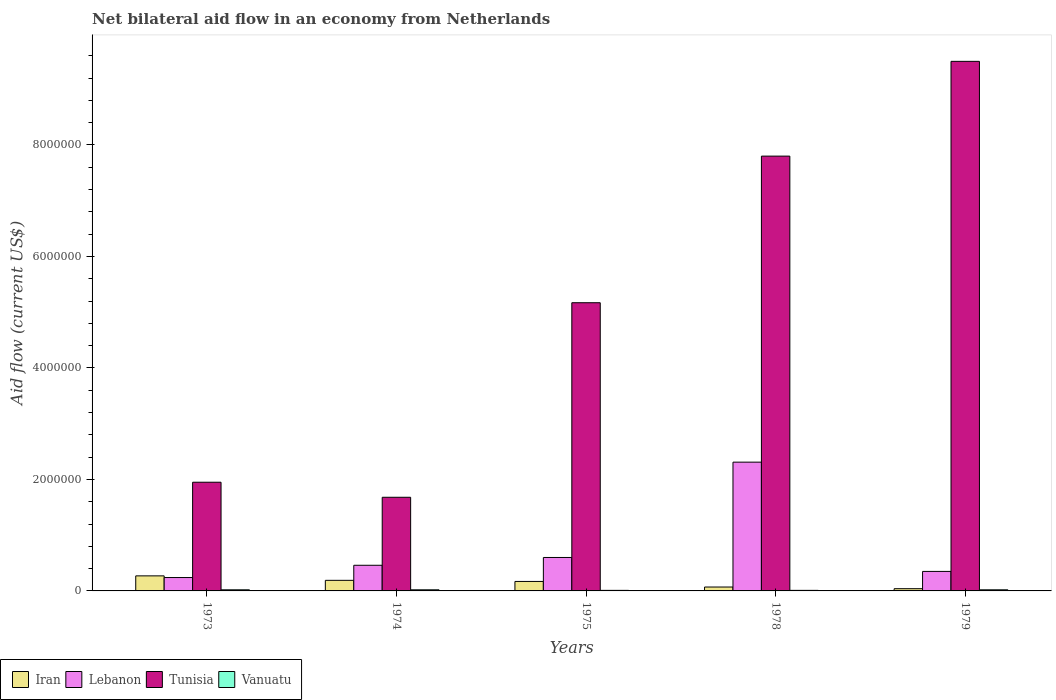How many different coloured bars are there?
Your response must be concise. 4. How many bars are there on the 3rd tick from the left?
Offer a very short reply. 4. What is the label of the 2nd group of bars from the left?
Your answer should be compact. 1974. In how many cases, is the number of bars for a given year not equal to the number of legend labels?
Provide a succinct answer. 0. What is the net bilateral aid flow in Iran in 1975?
Keep it short and to the point. 1.70e+05. Across all years, what is the maximum net bilateral aid flow in Iran?
Keep it short and to the point. 2.70e+05. Across all years, what is the minimum net bilateral aid flow in Tunisia?
Keep it short and to the point. 1.68e+06. In which year was the net bilateral aid flow in Vanuatu maximum?
Provide a short and direct response. 1973. In which year was the net bilateral aid flow in Tunisia minimum?
Keep it short and to the point. 1974. What is the total net bilateral aid flow in Vanuatu in the graph?
Provide a succinct answer. 8.00e+04. What is the difference between the net bilateral aid flow in Iran in 1975 and that in 1978?
Keep it short and to the point. 1.00e+05. What is the average net bilateral aid flow in Vanuatu per year?
Provide a short and direct response. 1.60e+04. In the year 1974, what is the difference between the net bilateral aid flow in Lebanon and net bilateral aid flow in Vanuatu?
Your answer should be very brief. 4.40e+05. What is the difference between the highest and the second highest net bilateral aid flow in Lebanon?
Offer a very short reply. 1.71e+06. What is the difference between the highest and the lowest net bilateral aid flow in Lebanon?
Give a very brief answer. 2.07e+06. In how many years, is the net bilateral aid flow in Lebanon greater than the average net bilateral aid flow in Lebanon taken over all years?
Ensure brevity in your answer.  1. Is the sum of the net bilateral aid flow in Iran in 1978 and 1979 greater than the maximum net bilateral aid flow in Vanuatu across all years?
Ensure brevity in your answer.  Yes. Is it the case that in every year, the sum of the net bilateral aid flow in Vanuatu and net bilateral aid flow in Iran is greater than the sum of net bilateral aid flow in Tunisia and net bilateral aid flow in Lebanon?
Offer a very short reply. Yes. What does the 1st bar from the left in 1978 represents?
Keep it short and to the point. Iran. What does the 4th bar from the right in 1978 represents?
Keep it short and to the point. Iran. Are all the bars in the graph horizontal?
Provide a short and direct response. No. Are the values on the major ticks of Y-axis written in scientific E-notation?
Make the answer very short. No. Where does the legend appear in the graph?
Your answer should be compact. Bottom left. How are the legend labels stacked?
Give a very brief answer. Horizontal. What is the title of the graph?
Make the answer very short. Net bilateral aid flow in an economy from Netherlands. What is the label or title of the X-axis?
Keep it short and to the point. Years. What is the label or title of the Y-axis?
Keep it short and to the point. Aid flow (current US$). What is the Aid flow (current US$) in Iran in 1973?
Make the answer very short. 2.70e+05. What is the Aid flow (current US$) in Tunisia in 1973?
Provide a short and direct response. 1.95e+06. What is the Aid flow (current US$) of Vanuatu in 1973?
Provide a short and direct response. 2.00e+04. What is the Aid flow (current US$) of Tunisia in 1974?
Your answer should be compact. 1.68e+06. What is the Aid flow (current US$) of Vanuatu in 1974?
Ensure brevity in your answer.  2.00e+04. What is the Aid flow (current US$) in Lebanon in 1975?
Give a very brief answer. 6.00e+05. What is the Aid flow (current US$) of Tunisia in 1975?
Your response must be concise. 5.17e+06. What is the Aid flow (current US$) of Lebanon in 1978?
Your answer should be compact. 2.31e+06. What is the Aid flow (current US$) in Tunisia in 1978?
Offer a very short reply. 7.80e+06. What is the Aid flow (current US$) of Iran in 1979?
Provide a succinct answer. 4.00e+04. What is the Aid flow (current US$) in Lebanon in 1979?
Keep it short and to the point. 3.50e+05. What is the Aid flow (current US$) of Tunisia in 1979?
Make the answer very short. 9.50e+06. What is the Aid flow (current US$) in Vanuatu in 1979?
Keep it short and to the point. 2.00e+04. Across all years, what is the maximum Aid flow (current US$) of Lebanon?
Keep it short and to the point. 2.31e+06. Across all years, what is the maximum Aid flow (current US$) of Tunisia?
Offer a very short reply. 9.50e+06. Across all years, what is the maximum Aid flow (current US$) of Vanuatu?
Provide a short and direct response. 2.00e+04. Across all years, what is the minimum Aid flow (current US$) in Iran?
Ensure brevity in your answer.  4.00e+04. Across all years, what is the minimum Aid flow (current US$) of Lebanon?
Offer a terse response. 2.40e+05. Across all years, what is the minimum Aid flow (current US$) of Tunisia?
Your answer should be compact. 1.68e+06. What is the total Aid flow (current US$) of Iran in the graph?
Your answer should be compact. 7.40e+05. What is the total Aid flow (current US$) of Lebanon in the graph?
Your response must be concise. 3.96e+06. What is the total Aid flow (current US$) of Tunisia in the graph?
Provide a short and direct response. 2.61e+07. What is the total Aid flow (current US$) in Vanuatu in the graph?
Give a very brief answer. 8.00e+04. What is the difference between the Aid flow (current US$) of Tunisia in 1973 and that in 1974?
Offer a terse response. 2.70e+05. What is the difference between the Aid flow (current US$) of Iran in 1973 and that in 1975?
Offer a terse response. 1.00e+05. What is the difference between the Aid flow (current US$) in Lebanon in 1973 and that in 1975?
Provide a succinct answer. -3.60e+05. What is the difference between the Aid flow (current US$) in Tunisia in 1973 and that in 1975?
Keep it short and to the point. -3.22e+06. What is the difference between the Aid flow (current US$) in Iran in 1973 and that in 1978?
Your answer should be very brief. 2.00e+05. What is the difference between the Aid flow (current US$) in Lebanon in 1973 and that in 1978?
Offer a terse response. -2.07e+06. What is the difference between the Aid flow (current US$) in Tunisia in 1973 and that in 1978?
Provide a short and direct response. -5.85e+06. What is the difference between the Aid flow (current US$) of Vanuatu in 1973 and that in 1978?
Your answer should be compact. 10000. What is the difference between the Aid flow (current US$) of Lebanon in 1973 and that in 1979?
Give a very brief answer. -1.10e+05. What is the difference between the Aid flow (current US$) in Tunisia in 1973 and that in 1979?
Keep it short and to the point. -7.55e+06. What is the difference between the Aid flow (current US$) in Vanuatu in 1973 and that in 1979?
Give a very brief answer. 0. What is the difference between the Aid flow (current US$) in Iran in 1974 and that in 1975?
Make the answer very short. 2.00e+04. What is the difference between the Aid flow (current US$) of Tunisia in 1974 and that in 1975?
Offer a terse response. -3.49e+06. What is the difference between the Aid flow (current US$) of Vanuatu in 1974 and that in 1975?
Your answer should be compact. 10000. What is the difference between the Aid flow (current US$) of Iran in 1974 and that in 1978?
Your answer should be very brief. 1.20e+05. What is the difference between the Aid flow (current US$) of Lebanon in 1974 and that in 1978?
Offer a very short reply. -1.85e+06. What is the difference between the Aid flow (current US$) in Tunisia in 1974 and that in 1978?
Keep it short and to the point. -6.12e+06. What is the difference between the Aid flow (current US$) in Tunisia in 1974 and that in 1979?
Ensure brevity in your answer.  -7.82e+06. What is the difference between the Aid flow (current US$) of Vanuatu in 1974 and that in 1979?
Make the answer very short. 0. What is the difference between the Aid flow (current US$) in Lebanon in 1975 and that in 1978?
Provide a short and direct response. -1.71e+06. What is the difference between the Aid flow (current US$) in Tunisia in 1975 and that in 1978?
Offer a very short reply. -2.63e+06. What is the difference between the Aid flow (current US$) of Vanuatu in 1975 and that in 1978?
Provide a short and direct response. 0. What is the difference between the Aid flow (current US$) in Tunisia in 1975 and that in 1979?
Ensure brevity in your answer.  -4.33e+06. What is the difference between the Aid flow (current US$) of Vanuatu in 1975 and that in 1979?
Provide a short and direct response. -10000. What is the difference between the Aid flow (current US$) in Iran in 1978 and that in 1979?
Your response must be concise. 3.00e+04. What is the difference between the Aid flow (current US$) in Lebanon in 1978 and that in 1979?
Keep it short and to the point. 1.96e+06. What is the difference between the Aid flow (current US$) of Tunisia in 1978 and that in 1979?
Your response must be concise. -1.70e+06. What is the difference between the Aid flow (current US$) in Iran in 1973 and the Aid flow (current US$) in Lebanon in 1974?
Your answer should be compact. -1.90e+05. What is the difference between the Aid flow (current US$) of Iran in 1973 and the Aid flow (current US$) of Tunisia in 1974?
Your answer should be compact. -1.41e+06. What is the difference between the Aid flow (current US$) of Lebanon in 1973 and the Aid flow (current US$) of Tunisia in 1974?
Offer a terse response. -1.44e+06. What is the difference between the Aid flow (current US$) of Lebanon in 1973 and the Aid flow (current US$) of Vanuatu in 1974?
Make the answer very short. 2.20e+05. What is the difference between the Aid flow (current US$) in Tunisia in 1973 and the Aid flow (current US$) in Vanuatu in 1974?
Your response must be concise. 1.93e+06. What is the difference between the Aid flow (current US$) in Iran in 1973 and the Aid flow (current US$) in Lebanon in 1975?
Provide a short and direct response. -3.30e+05. What is the difference between the Aid flow (current US$) in Iran in 1973 and the Aid flow (current US$) in Tunisia in 1975?
Your response must be concise. -4.90e+06. What is the difference between the Aid flow (current US$) in Iran in 1973 and the Aid flow (current US$) in Vanuatu in 1975?
Give a very brief answer. 2.60e+05. What is the difference between the Aid flow (current US$) in Lebanon in 1973 and the Aid flow (current US$) in Tunisia in 1975?
Offer a terse response. -4.93e+06. What is the difference between the Aid flow (current US$) in Tunisia in 1973 and the Aid flow (current US$) in Vanuatu in 1975?
Provide a short and direct response. 1.94e+06. What is the difference between the Aid flow (current US$) in Iran in 1973 and the Aid flow (current US$) in Lebanon in 1978?
Keep it short and to the point. -2.04e+06. What is the difference between the Aid flow (current US$) of Iran in 1973 and the Aid flow (current US$) of Tunisia in 1978?
Make the answer very short. -7.53e+06. What is the difference between the Aid flow (current US$) of Iran in 1973 and the Aid flow (current US$) of Vanuatu in 1978?
Your answer should be compact. 2.60e+05. What is the difference between the Aid flow (current US$) of Lebanon in 1973 and the Aid flow (current US$) of Tunisia in 1978?
Provide a short and direct response. -7.56e+06. What is the difference between the Aid flow (current US$) of Lebanon in 1973 and the Aid flow (current US$) of Vanuatu in 1978?
Give a very brief answer. 2.30e+05. What is the difference between the Aid flow (current US$) in Tunisia in 1973 and the Aid flow (current US$) in Vanuatu in 1978?
Ensure brevity in your answer.  1.94e+06. What is the difference between the Aid flow (current US$) in Iran in 1973 and the Aid flow (current US$) in Tunisia in 1979?
Give a very brief answer. -9.23e+06. What is the difference between the Aid flow (current US$) in Iran in 1973 and the Aid flow (current US$) in Vanuatu in 1979?
Give a very brief answer. 2.50e+05. What is the difference between the Aid flow (current US$) of Lebanon in 1973 and the Aid flow (current US$) of Tunisia in 1979?
Your answer should be compact. -9.26e+06. What is the difference between the Aid flow (current US$) of Tunisia in 1973 and the Aid flow (current US$) of Vanuatu in 1979?
Provide a short and direct response. 1.93e+06. What is the difference between the Aid flow (current US$) of Iran in 1974 and the Aid flow (current US$) of Lebanon in 1975?
Your answer should be very brief. -4.10e+05. What is the difference between the Aid flow (current US$) in Iran in 1974 and the Aid flow (current US$) in Tunisia in 1975?
Offer a terse response. -4.98e+06. What is the difference between the Aid flow (current US$) of Iran in 1974 and the Aid flow (current US$) of Vanuatu in 1975?
Your answer should be very brief. 1.80e+05. What is the difference between the Aid flow (current US$) of Lebanon in 1974 and the Aid flow (current US$) of Tunisia in 1975?
Keep it short and to the point. -4.71e+06. What is the difference between the Aid flow (current US$) of Lebanon in 1974 and the Aid flow (current US$) of Vanuatu in 1975?
Your answer should be compact. 4.50e+05. What is the difference between the Aid flow (current US$) of Tunisia in 1974 and the Aid flow (current US$) of Vanuatu in 1975?
Give a very brief answer. 1.67e+06. What is the difference between the Aid flow (current US$) in Iran in 1974 and the Aid flow (current US$) in Lebanon in 1978?
Your answer should be compact. -2.12e+06. What is the difference between the Aid flow (current US$) in Iran in 1974 and the Aid flow (current US$) in Tunisia in 1978?
Offer a terse response. -7.61e+06. What is the difference between the Aid flow (current US$) of Lebanon in 1974 and the Aid flow (current US$) of Tunisia in 1978?
Your answer should be compact. -7.34e+06. What is the difference between the Aid flow (current US$) of Lebanon in 1974 and the Aid flow (current US$) of Vanuatu in 1978?
Your response must be concise. 4.50e+05. What is the difference between the Aid flow (current US$) of Tunisia in 1974 and the Aid flow (current US$) of Vanuatu in 1978?
Offer a terse response. 1.67e+06. What is the difference between the Aid flow (current US$) in Iran in 1974 and the Aid flow (current US$) in Lebanon in 1979?
Your answer should be very brief. -1.60e+05. What is the difference between the Aid flow (current US$) of Iran in 1974 and the Aid flow (current US$) of Tunisia in 1979?
Offer a terse response. -9.31e+06. What is the difference between the Aid flow (current US$) of Iran in 1974 and the Aid flow (current US$) of Vanuatu in 1979?
Give a very brief answer. 1.70e+05. What is the difference between the Aid flow (current US$) in Lebanon in 1974 and the Aid flow (current US$) in Tunisia in 1979?
Offer a terse response. -9.04e+06. What is the difference between the Aid flow (current US$) of Lebanon in 1974 and the Aid flow (current US$) of Vanuatu in 1979?
Ensure brevity in your answer.  4.40e+05. What is the difference between the Aid flow (current US$) of Tunisia in 1974 and the Aid flow (current US$) of Vanuatu in 1979?
Keep it short and to the point. 1.66e+06. What is the difference between the Aid flow (current US$) in Iran in 1975 and the Aid flow (current US$) in Lebanon in 1978?
Your answer should be very brief. -2.14e+06. What is the difference between the Aid flow (current US$) in Iran in 1975 and the Aid flow (current US$) in Tunisia in 1978?
Give a very brief answer. -7.63e+06. What is the difference between the Aid flow (current US$) in Lebanon in 1975 and the Aid flow (current US$) in Tunisia in 1978?
Provide a short and direct response. -7.20e+06. What is the difference between the Aid flow (current US$) in Lebanon in 1975 and the Aid flow (current US$) in Vanuatu in 1978?
Offer a very short reply. 5.90e+05. What is the difference between the Aid flow (current US$) in Tunisia in 1975 and the Aid flow (current US$) in Vanuatu in 1978?
Give a very brief answer. 5.16e+06. What is the difference between the Aid flow (current US$) in Iran in 1975 and the Aid flow (current US$) in Tunisia in 1979?
Offer a very short reply. -9.33e+06. What is the difference between the Aid flow (current US$) in Lebanon in 1975 and the Aid flow (current US$) in Tunisia in 1979?
Make the answer very short. -8.90e+06. What is the difference between the Aid flow (current US$) in Lebanon in 1975 and the Aid flow (current US$) in Vanuatu in 1979?
Ensure brevity in your answer.  5.80e+05. What is the difference between the Aid flow (current US$) of Tunisia in 1975 and the Aid flow (current US$) of Vanuatu in 1979?
Make the answer very short. 5.15e+06. What is the difference between the Aid flow (current US$) in Iran in 1978 and the Aid flow (current US$) in Lebanon in 1979?
Provide a short and direct response. -2.80e+05. What is the difference between the Aid flow (current US$) in Iran in 1978 and the Aid flow (current US$) in Tunisia in 1979?
Provide a succinct answer. -9.43e+06. What is the difference between the Aid flow (current US$) in Iran in 1978 and the Aid flow (current US$) in Vanuatu in 1979?
Offer a terse response. 5.00e+04. What is the difference between the Aid flow (current US$) of Lebanon in 1978 and the Aid flow (current US$) of Tunisia in 1979?
Provide a short and direct response. -7.19e+06. What is the difference between the Aid flow (current US$) in Lebanon in 1978 and the Aid flow (current US$) in Vanuatu in 1979?
Your answer should be very brief. 2.29e+06. What is the difference between the Aid flow (current US$) of Tunisia in 1978 and the Aid flow (current US$) of Vanuatu in 1979?
Offer a terse response. 7.78e+06. What is the average Aid flow (current US$) of Iran per year?
Give a very brief answer. 1.48e+05. What is the average Aid flow (current US$) of Lebanon per year?
Keep it short and to the point. 7.92e+05. What is the average Aid flow (current US$) in Tunisia per year?
Ensure brevity in your answer.  5.22e+06. What is the average Aid flow (current US$) in Vanuatu per year?
Give a very brief answer. 1.60e+04. In the year 1973, what is the difference between the Aid flow (current US$) in Iran and Aid flow (current US$) in Tunisia?
Your answer should be very brief. -1.68e+06. In the year 1973, what is the difference between the Aid flow (current US$) in Lebanon and Aid flow (current US$) in Tunisia?
Your answer should be compact. -1.71e+06. In the year 1973, what is the difference between the Aid flow (current US$) in Lebanon and Aid flow (current US$) in Vanuatu?
Ensure brevity in your answer.  2.20e+05. In the year 1973, what is the difference between the Aid flow (current US$) of Tunisia and Aid flow (current US$) of Vanuatu?
Ensure brevity in your answer.  1.93e+06. In the year 1974, what is the difference between the Aid flow (current US$) in Iran and Aid flow (current US$) in Tunisia?
Provide a succinct answer. -1.49e+06. In the year 1974, what is the difference between the Aid flow (current US$) in Iran and Aid flow (current US$) in Vanuatu?
Give a very brief answer. 1.70e+05. In the year 1974, what is the difference between the Aid flow (current US$) in Lebanon and Aid flow (current US$) in Tunisia?
Give a very brief answer. -1.22e+06. In the year 1974, what is the difference between the Aid flow (current US$) of Tunisia and Aid flow (current US$) of Vanuatu?
Make the answer very short. 1.66e+06. In the year 1975, what is the difference between the Aid flow (current US$) of Iran and Aid flow (current US$) of Lebanon?
Give a very brief answer. -4.30e+05. In the year 1975, what is the difference between the Aid flow (current US$) of Iran and Aid flow (current US$) of Tunisia?
Your response must be concise. -5.00e+06. In the year 1975, what is the difference between the Aid flow (current US$) in Lebanon and Aid flow (current US$) in Tunisia?
Offer a very short reply. -4.57e+06. In the year 1975, what is the difference between the Aid flow (current US$) in Lebanon and Aid flow (current US$) in Vanuatu?
Make the answer very short. 5.90e+05. In the year 1975, what is the difference between the Aid flow (current US$) of Tunisia and Aid flow (current US$) of Vanuatu?
Give a very brief answer. 5.16e+06. In the year 1978, what is the difference between the Aid flow (current US$) of Iran and Aid flow (current US$) of Lebanon?
Your response must be concise. -2.24e+06. In the year 1978, what is the difference between the Aid flow (current US$) in Iran and Aid flow (current US$) in Tunisia?
Your answer should be very brief. -7.73e+06. In the year 1978, what is the difference between the Aid flow (current US$) in Lebanon and Aid flow (current US$) in Tunisia?
Your answer should be very brief. -5.49e+06. In the year 1978, what is the difference between the Aid flow (current US$) in Lebanon and Aid flow (current US$) in Vanuatu?
Offer a terse response. 2.30e+06. In the year 1978, what is the difference between the Aid flow (current US$) in Tunisia and Aid flow (current US$) in Vanuatu?
Make the answer very short. 7.79e+06. In the year 1979, what is the difference between the Aid flow (current US$) in Iran and Aid flow (current US$) in Lebanon?
Offer a very short reply. -3.10e+05. In the year 1979, what is the difference between the Aid flow (current US$) of Iran and Aid flow (current US$) of Tunisia?
Give a very brief answer. -9.46e+06. In the year 1979, what is the difference between the Aid flow (current US$) of Lebanon and Aid flow (current US$) of Tunisia?
Keep it short and to the point. -9.15e+06. In the year 1979, what is the difference between the Aid flow (current US$) in Lebanon and Aid flow (current US$) in Vanuatu?
Give a very brief answer. 3.30e+05. In the year 1979, what is the difference between the Aid flow (current US$) in Tunisia and Aid flow (current US$) in Vanuatu?
Offer a very short reply. 9.48e+06. What is the ratio of the Aid flow (current US$) of Iran in 1973 to that in 1974?
Your answer should be very brief. 1.42. What is the ratio of the Aid flow (current US$) in Lebanon in 1973 to that in 1974?
Keep it short and to the point. 0.52. What is the ratio of the Aid flow (current US$) of Tunisia in 1973 to that in 1974?
Provide a succinct answer. 1.16. What is the ratio of the Aid flow (current US$) in Vanuatu in 1973 to that in 1974?
Ensure brevity in your answer.  1. What is the ratio of the Aid flow (current US$) of Iran in 1973 to that in 1975?
Keep it short and to the point. 1.59. What is the ratio of the Aid flow (current US$) of Lebanon in 1973 to that in 1975?
Offer a terse response. 0.4. What is the ratio of the Aid flow (current US$) in Tunisia in 1973 to that in 1975?
Ensure brevity in your answer.  0.38. What is the ratio of the Aid flow (current US$) of Vanuatu in 1973 to that in 1975?
Ensure brevity in your answer.  2. What is the ratio of the Aid flow (current US$) in Iran in 1973 to that in 1978?
Make the answer very short. 3.86. What is the ratio of the Aid flow (current US$) in Lebanon in 1973 to that in 1978?
Keep it short and to the point. 0.1. What is the ratio of the Aid flow (current US$) of Tunisia in 1973 to that in 1978?
Your answer should be compact. 0.25. What is the ratio of the Aid flow (current US$) of Iran in 1973 to that in 1979?
Provide a short and direct response. 6.75. What is the ratio of the Aid flow (current US$) of Lebanon in 1973 to that in 1979?
Ensure brevity in your answer.  0.69. What is the ratio of the Aid flow (current US$) of Tunisia in 1973 to that in 1979?
Provide a succinct answer. 0.21. What is the ratio of the Aid flow (current US$) of Iran in 1974 to that in 1975?
Your answer should be very brief. 1.12. What is the ratio of the Aid flow (current US$) in Lebanon in 1974 to that in 1975?
Your response must be concise. 0.77. What is the ratio of the Aid flow (current US$) in Tunisia in 1974 to that in 1975?
Keep it short and to the point. 0.33. What is the ratio of the Aid flow (current US$) of Vanuatu in 1974 to that in 1975?
Offer a very short reply. 2. What is the ratio of the Aid flow (current US$) in Iran in 1974 to that in 1978?
Provide a succinct answer. 2.71. What is the ratio of the Aid flow (current US$) in Lebanon in 1974 to that in 1978?
Offer a terse response. 0.2. What is the ratio of the Aid flow (current US$) of Tunisia in 1974 to that in 1978?
Offer a terse response. 0.22. What is the ratio of the Aid flow (current US$) of Vanuatu in 1974 to that in 1978?
Keep it short and to the point. 2. What is the ratio of the Aid flow (current US$) in Iran in 1974 to that in 1979?
Offer a terse response. 4.75. What is the ratio of the Aid flow (current US$) of Lebanon in 1974 to that in 1979?
Make the answer very short. 1.31. What is the ratio of the Aid flow (current US$) in Tunisia in 1974 to that in 1979?
Offer a very short reply. 0.18. What is the ratio of the Aid flow (current US$) of Iran in 1975 to that in 1978?
Offer a terse response. 2.43. What is the ratio of the Aid flow (current US$) in Lebanon in 1975 to that in 1978?
Provide a short and direct response. 0.26. What is the ratio of the Aid flow (current US$) in Tunisia in 1975 to that in 1978?
Offer a very short reply. 0.66. What is the ratio of the Aid flow (current US$) in Vanuatu in 1975 to that in 1978?
Your answer should be compact. 1. What is the ratio of the Aid flow (current US$) of Iran in 1975 to that in 1979?
Provide a succinct answer. 4.25. What is the ratio of the Aid flow (current US$) of Lebanon in 1975 to that in 1979?
Offer a terse response. 1.71. What is the ratio of the Aid flow (current US$) of Tunisia in 1975 to that in 1979?
Your answer should be compact. 0.54. What is the ratio of the Aid flow (current US$) in Lebanon in 1978 to that in 1979?
Provide a short and direct response. 6.6. What is the ratio of the Aid flow (current US$) in Tunisia in 1978 to that in 1979?
Ensure brevity in your answer.  0.82. What is the ratio of the Aid flow (current US$) of Vanuatu in 1978 to that in 1979?
Offer a very short reply. 0.5. What is the difference between the highest and the second highest Aid flow (current US$) in Iran?
Offer a terse response. 8.00e+04. What is the difference between the highest and the second highest Aid flow (current US$) of Lebanon?
Your response must be concise. 1.71e+06. What is the difference between the highest and the second highest Aid flow (current US$) in Tunisia?
Your response must be concise. 1.70e+06. What is the difference between the highest and the second highest Aid flow (current US$) of Vanuatu?
Your answer should be very brief. 0. What is the difference between the highest and the lowest Aid flow (current US$) in Lebanon?
Make the answer very short. 2.07e+06. What is the difference between the highest and the lowest Aid flow (current US$) of Tunisia?
Ensure brevity in your answer.  7.82e+06. 